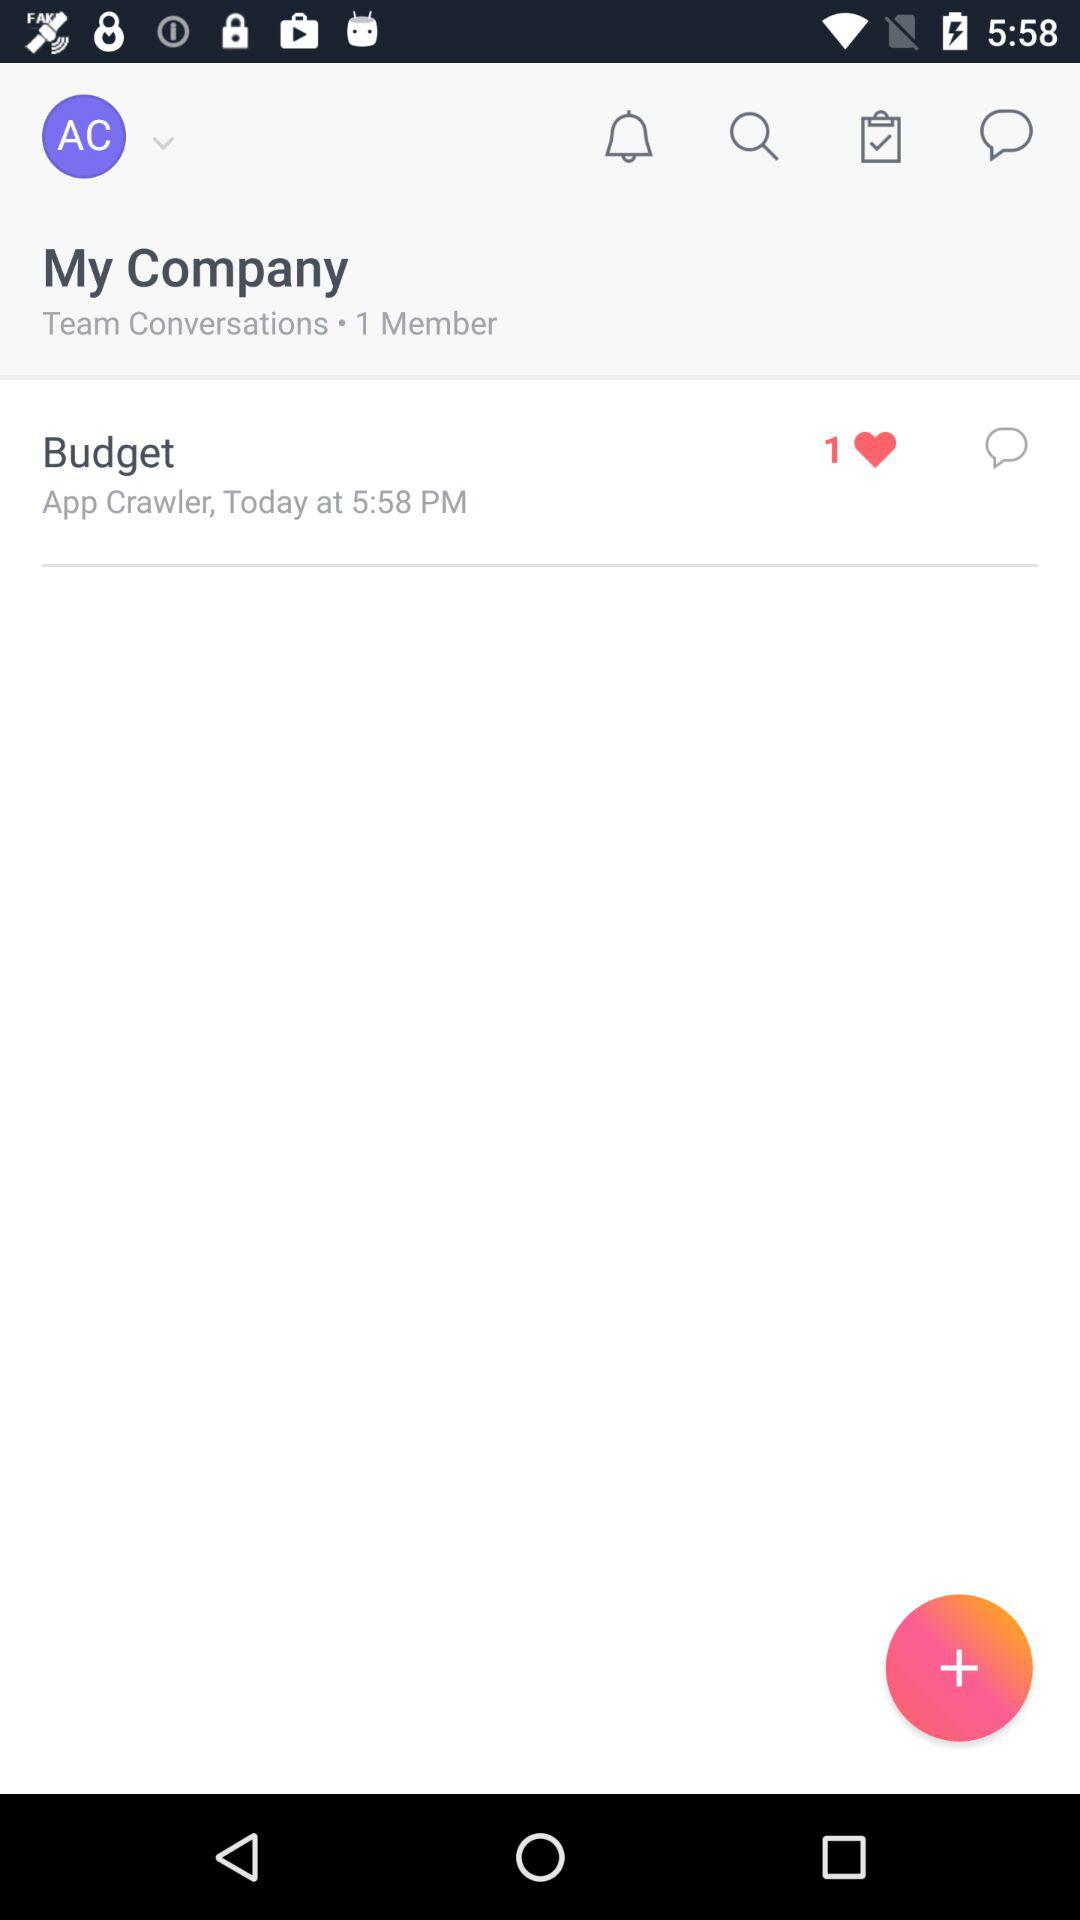How many members are there in team conversations? There is 1 member in team conversations. 